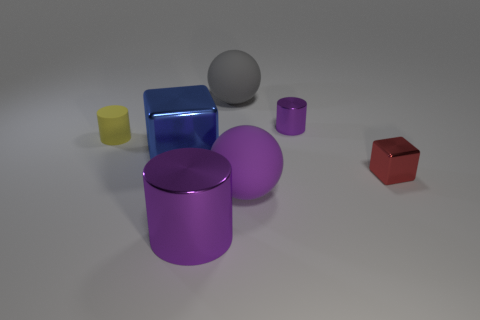Add 3 shiny cylinders. How many objects exist? 10 Subtract all blocks. How many objects are left? 5 Subtract all tiny red rubber cylinders. Subtract all purple spheres. How many objects are left? 6 Add 7 rubber cylinders. How many rubber cylinders are left? 8 Add 7 metal cylinders. How many metal cylinders exist? 9 Subtract 0 yellow spheres. How many objects are left? 7 